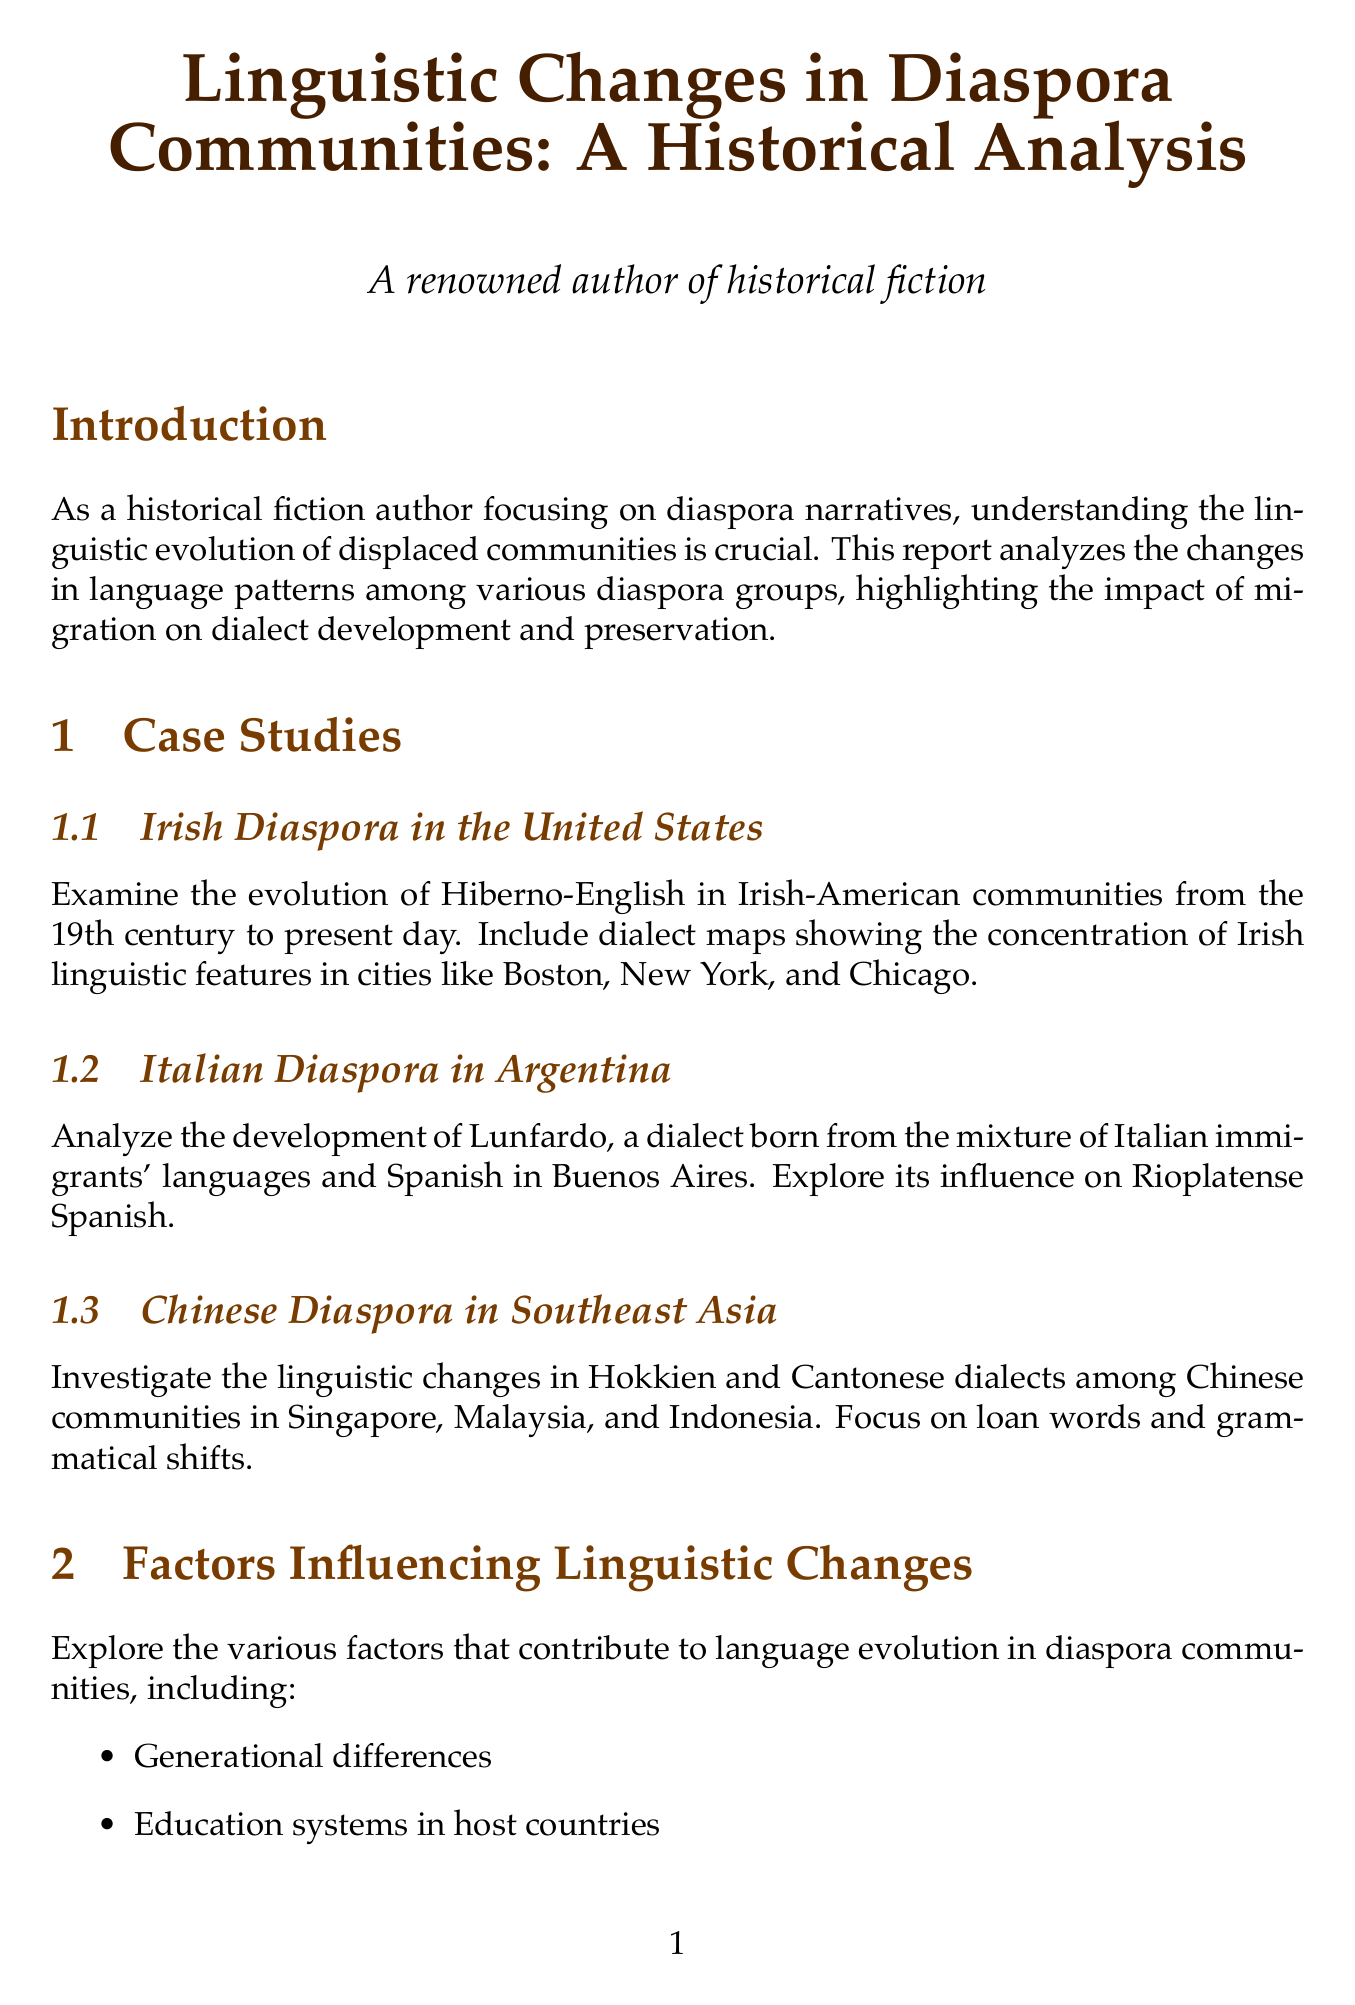What is the title of the report? The title of the report is stated at the beginning, providing the main subject of the analysis.
Answer: Linguistic Changes in Diaspora Communities: A Historical Analysis Who are the authors mentioned in the bibliography? The authors and their works are listed in the bibliography section, highlighting their contributions to the topic.
Answer: Hickey, Lo Bianco, Canagarajah What dialect is examined in the Irish Diaspora section? The section specifies the dialect being analyzed among the Irish-American communities since the 19th century.
Answer: Hiberno-English Which community's linguistic changes are investigated in Southeast Asia? The document describes the Chinese communities in specific countries, focusing on their dialects.
Answer: Hokkien and Cantonese What factor is not mentioned as influencing linguistic changes? The report lists various factors, and one factor must be identified as missing.
Answer: (Any factor not listed, e.g., Economic policies) How many case studies are presented in the report? The number of specific diaspora communities studied is outlined in the Case Studies section.
Answer: Three Which technology's impact is discussed in the report? The report addresses modern technology's role in language preservation within diaspora communities.
Answer: Social media What literary work is associated with Jhumpa Lahiri? The report examines specific works of authors representing diaspora narratives, identifying them in relation to their content.
Answer: The Namesake What is the main conclusion of the report? The conclusion summarizes the key findings regarding the subject matter, emphasizing its importance to the reader.
Answer: Dynamic nature of language evolution and its importance in preserving cultural identity 